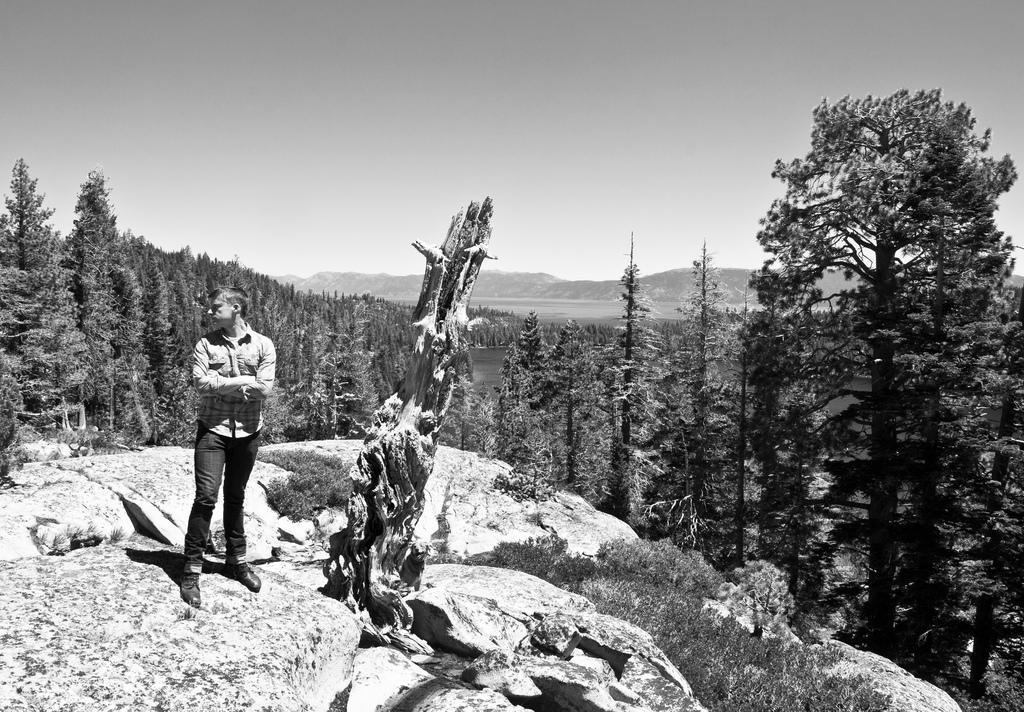What is the person in the image doing? The person is standing on a rock in the image. What can be seen in the background of the image? There are trees and mountains visible in the background of the image. What is the color scheme of the image? The image is in black and white. What type of record is being played by the person standing on the rock in the image? There is no record or music player visible in the image, so it cannot be determined if a record is being played. 